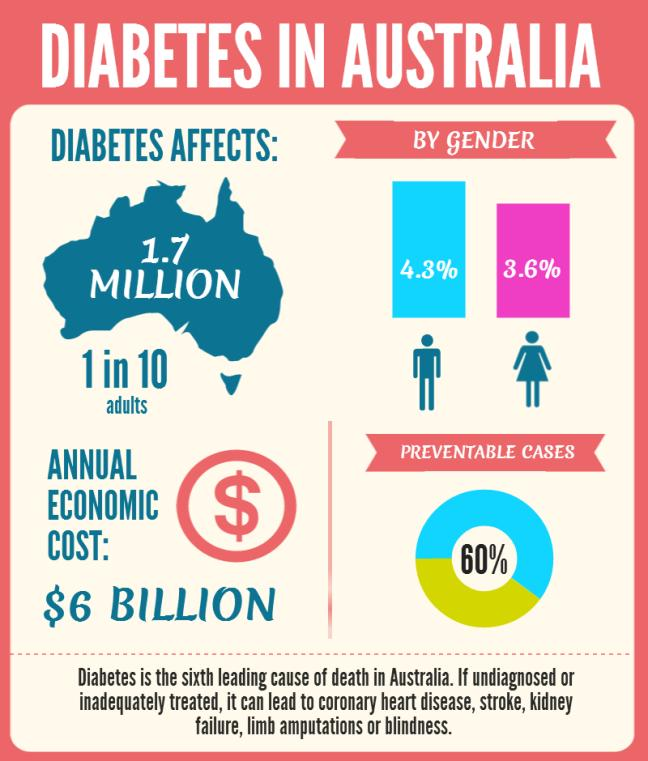Specify some key components in this picture. Approximately 3.6% of females are affected by diabetes. Diabetes has been shown to increase the risk of blindness and stroke. Diabetes can lead to kidney failure. Sixty percent of cases can be prevented. 